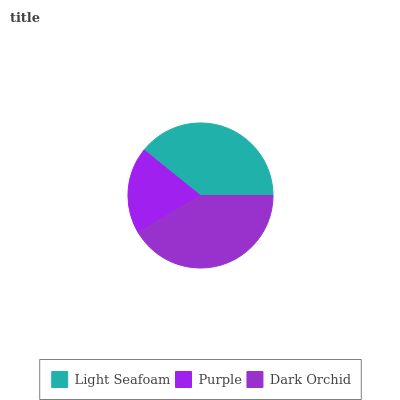Is Purple the minimum?
Answer yes or no. Yes. Is Dark Orchid the maximum?
Answer yes or no. Yes. Is Dark Orchid the minimum?
Answer yes or no. No. Is Purple the maximum?
Answer yes or no. No. Is Dark Orchid greater than Purple?
Answer yes or no. Yes. Is Purple less than Dark Orchid?
Answer yes or no. Yes. Is Purple greater than Dark Orchid?
Answer yes or no. No. Is Dark Orchid less than Purple?
Answer yes or no. No. Is Light Seafoam the high median?
Answer yes or no. Yes. Is Light Seafoam the low median?
Answer yes or no. Yes. Is Purple the high median?
Answer yes or no. No. Is Purple the low median?
Answer yes or no. No. 